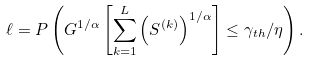<formula> <loc_0><loc_0><loc_500><loc_500>\ell = P \left ( G ^ { 1 / \alpha } \left [ \sum _ { k = 1 } ^ { L } { \left ( S ^ { ( k ) } \right ) ^ { 1 / \alpha } } \right ] \leq \gamma _ { t h } / \eta \right ) .</formula> 